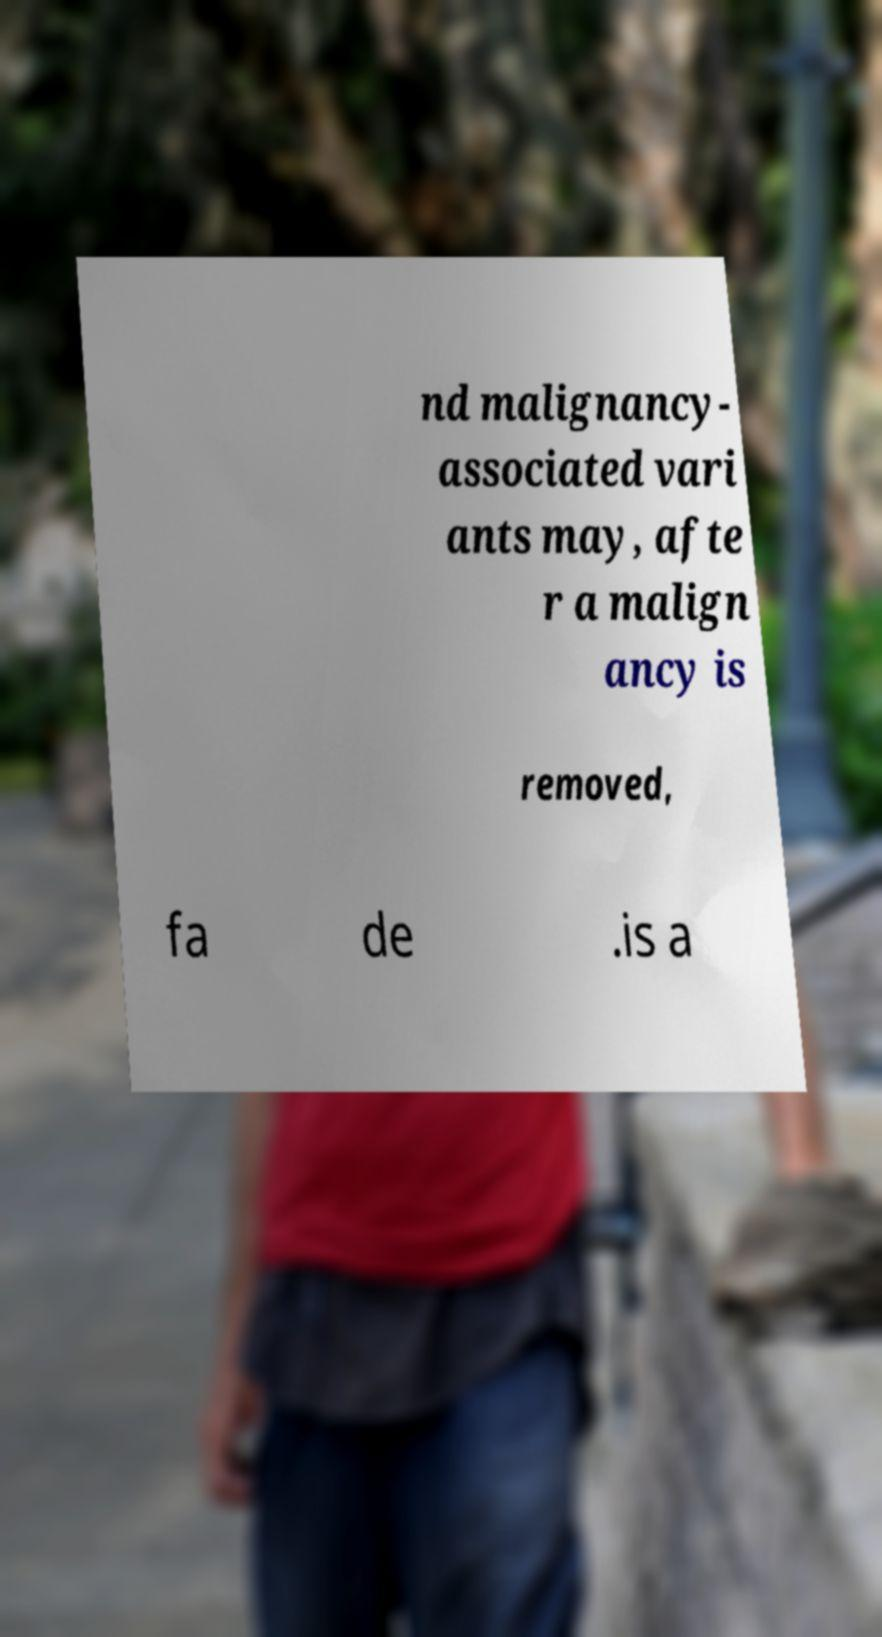I need the written content from this picture converted into text. Can you do that? nd malignancy- associated vari ants may, afte r a malign ancy is removed, fa de .is a 